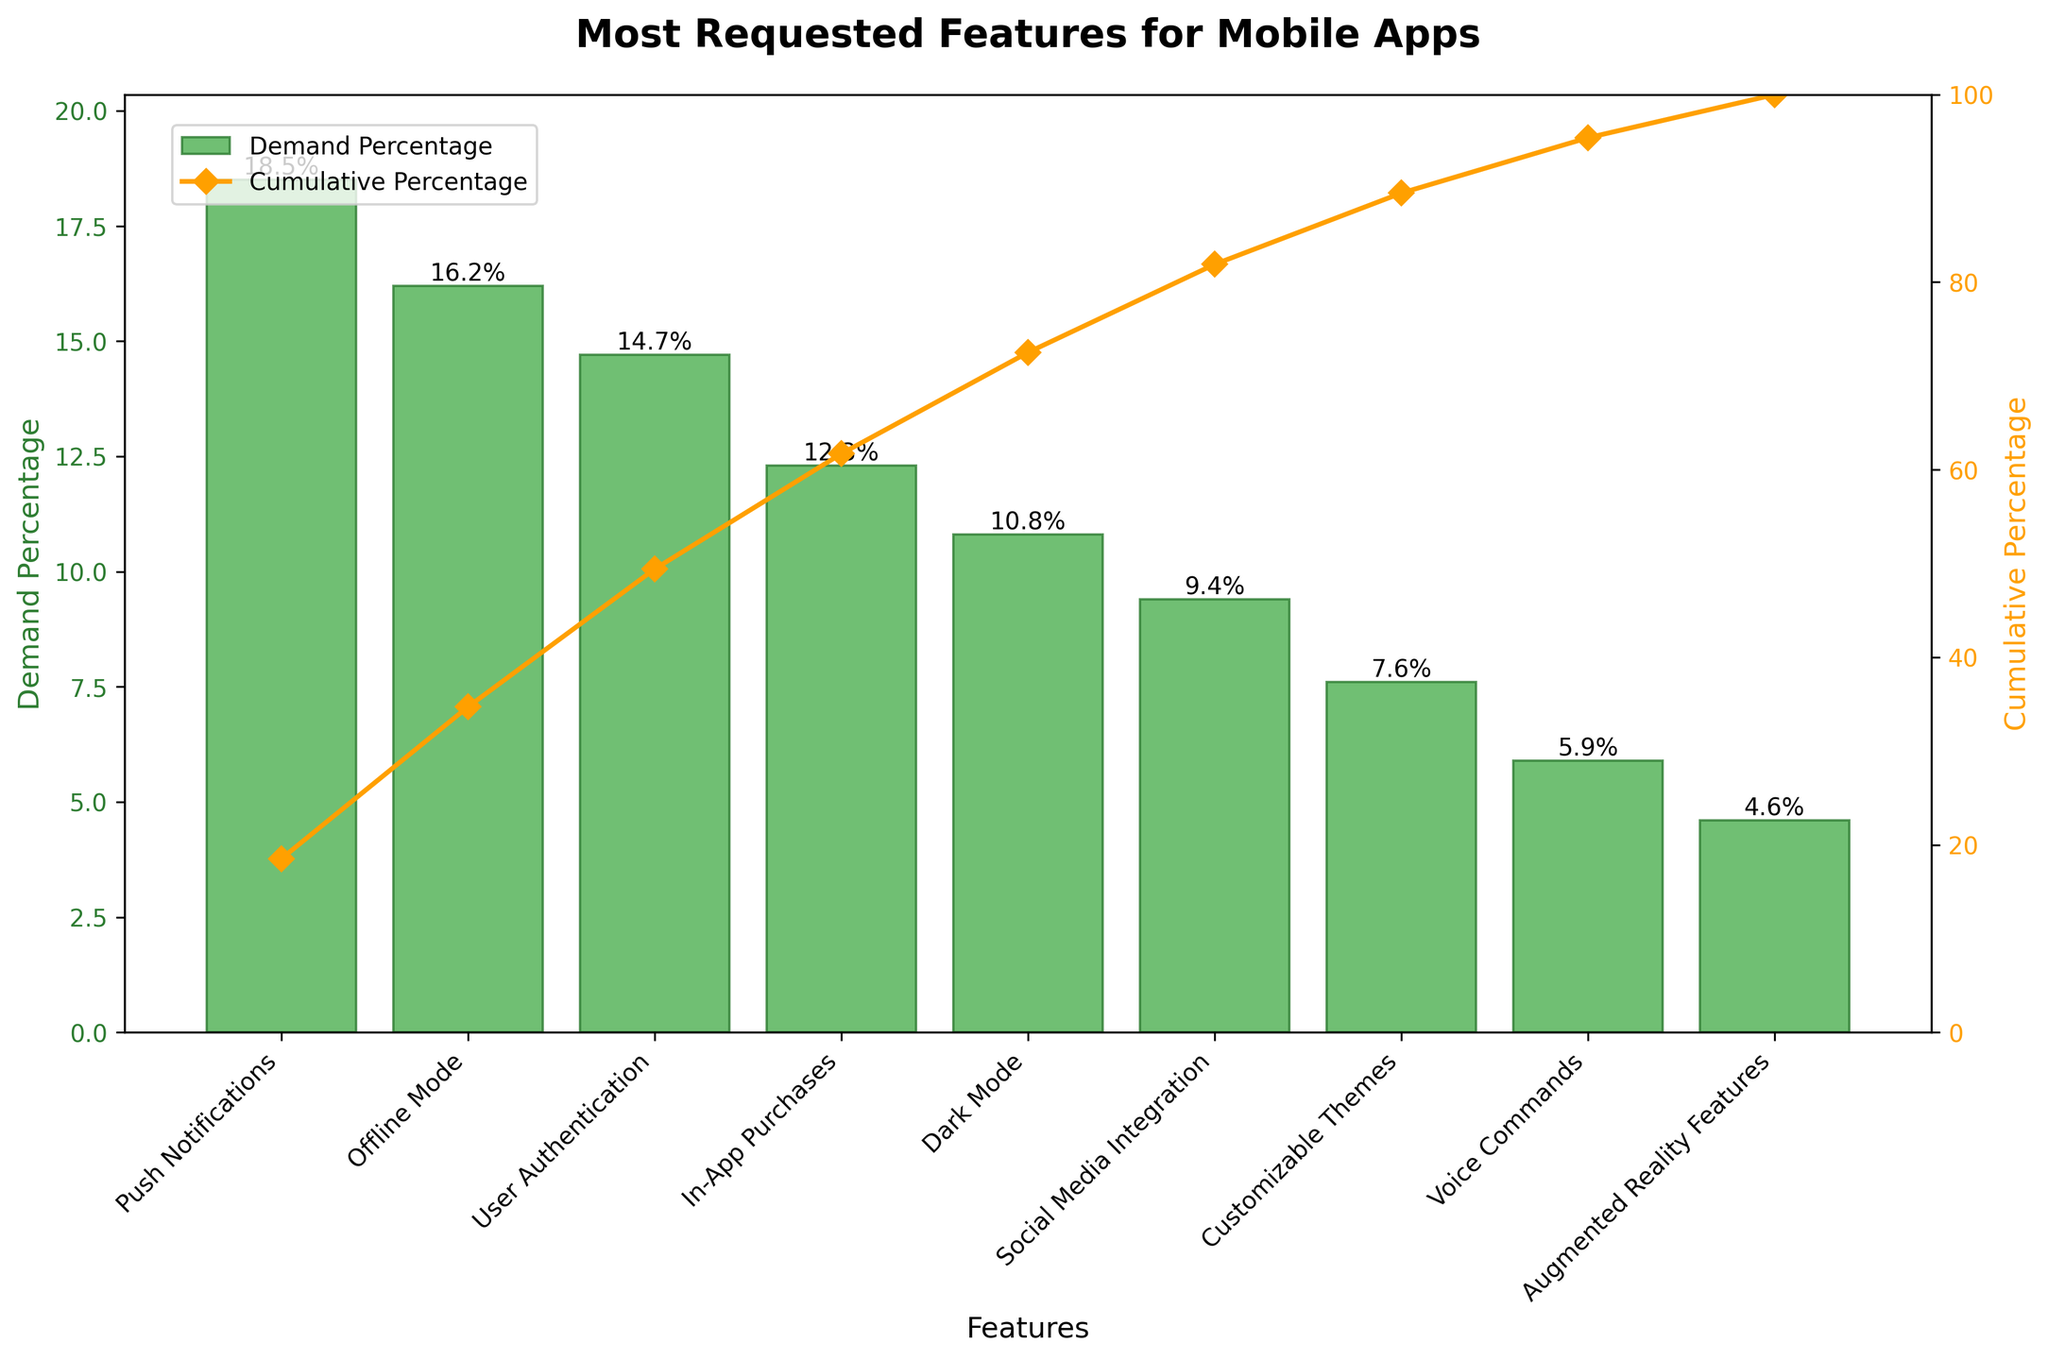What is the title of the chart? The title of the chart is typically displayed at the top of the figure. It provides overall context about the data being visualized.
Answer: Most Requested Features for Mobile Apps How many features are listed on the chart? The number of features can be determined by counting the bars along the x-axis of the chart.
Answer: 9 What feature has the highest demand percentage? To find the feature with the highest demand, look for the tallest bar in the chart.
Answer: Push Notifications What is the cumulative percentage after the third feature? The cumulative percentage after a certain feature can be found by looking at the line plot and reading the y-axis value corresponding to the third feature's position.
Answer: 49.4% How does the demand percentage for "Dark Mode" compare to "Social Media Integration"? To compare the demand percentages, locate the bars for "Dark Mode" and "Social Media Integration" and compare their heights.
Answer: Dark Mode has a higher demand percentage than Social Media Integration What is the sum of the demand percentages for "Offline Mode" and "In-App Purchases"? Add the demand percentages for the two features (16.2% + 12.3%) as given in the chart.
Answer: 28.5% Which feature contributes to crossing 50% in the cumulative percentage? Observe the cumulative percentage line and identify the feature at which it crosses the 50% mark.
Answer: User Authentication What is the range of percentages represented in the chart? The range can be found by subtracting the lowest demand percentage from the highest demand percentage (18.5% - 4.6%).
Answer: 13.9% What proportion of the total percentage do the three least requested features represent? Add the demand percentages of the three least requested features (Voice Commands: 5.9%, Augmented Reality Features: 4.6%, Customizable Themes: 7.6%) and divide by the total percentage (100%), then multiply by 100.
Answer: 18.1% How much more in demand are "Push Notifications" compared to "Voice Commands"? Subtract the demand percentage of "Voice Commands" from that of "Push Notifications" (18.5% - 5.9%).
Answer: 12.6% 